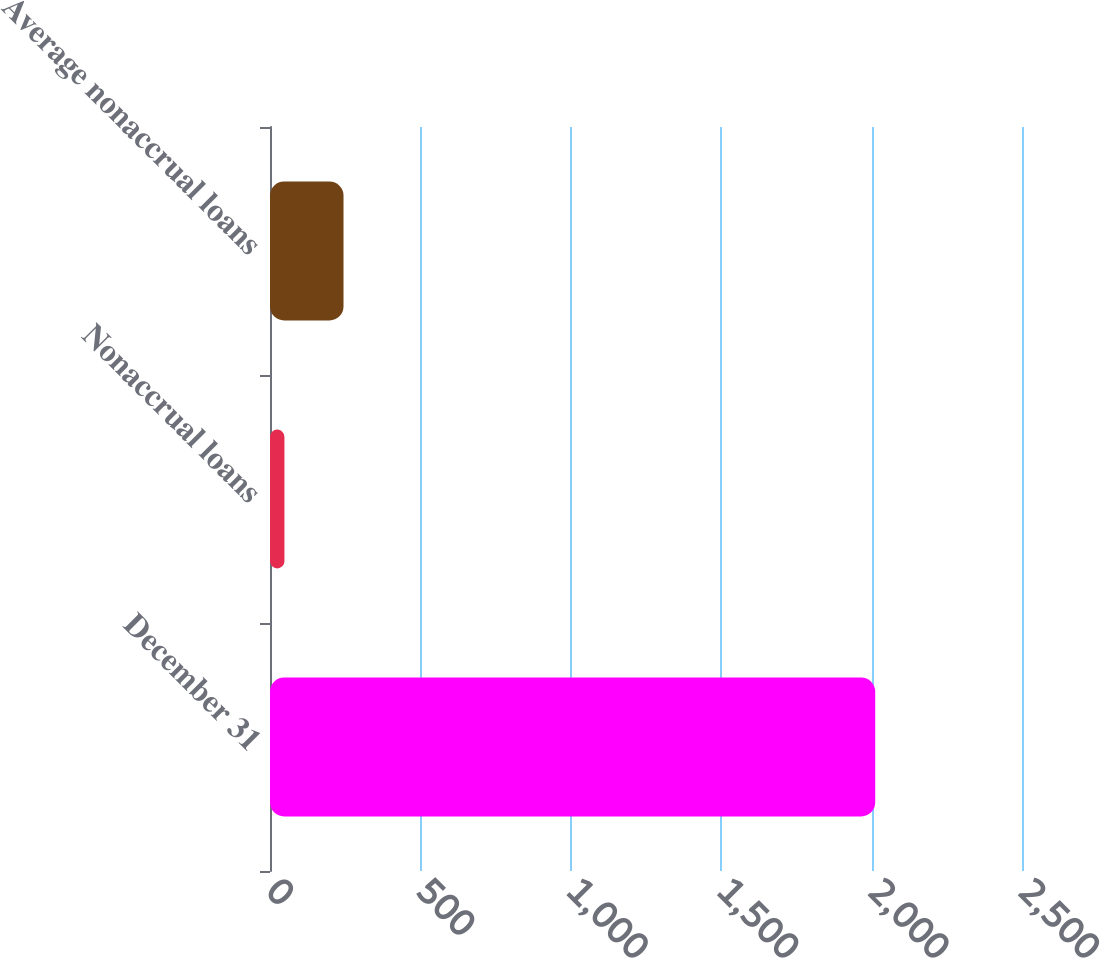Convert chart. <chart><loc_0><loc_0><loc_500><loc_500><bar_chart><fcel>December 31<fcel>Nonaccrual loans<fcel>Average nonaccrual loans<nl><fcel>2012<fcel>48<fcel>244.4<nl></chart> 